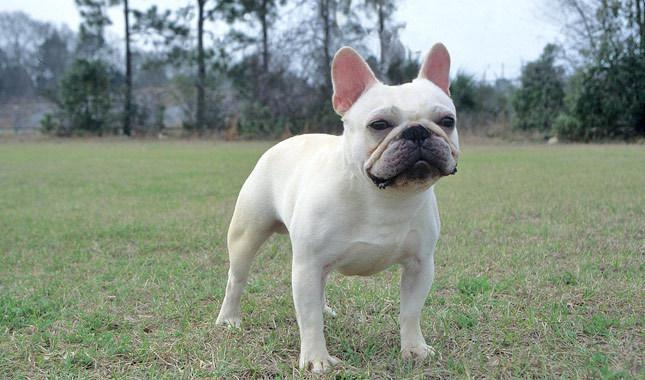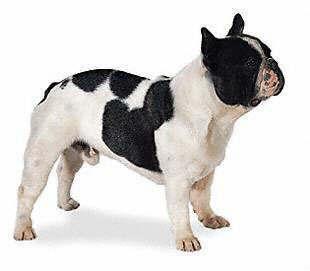The first image is the image on the left, the second image is the image on the right. Evaluate the accuracy of this statement regarding the images: "There are two young dogs.". Is it true? Answer yes or no. Yes. 